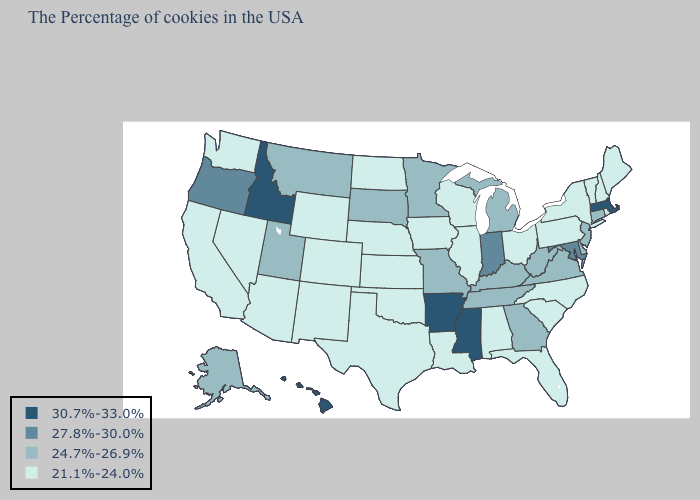Which states have the lowest value in the USA?
Keep it brief. Maine, Rhode Island, New Hampshire, Vermont, New York, Pennsylvania, North Carolina, South Carolina, Ohio, Florida, Alabama, Wisconsin, Illinois, Louisiana, Iowa, Kansas, Nebraska, Oklahoma, Texas, North Dakota, Wyoming, Colorado, New Mexico, Arizona, Nevada, California, Washington. Name the states that have a value in the range 21.1%-24.0%?
Give a very brief answer. Maine, Rhode Island, New Hampshire, Vermont, New York, Pennsylvania, North Carolina, South Carolina, Ohio, Florida, Alabama, Wisconsin, Illinois, Louisiana, Iowa, Kansas, Nebraska, Oklahoma, Texas, North Dakota, Wyoming, Colorado, New Mexico, Arizona, Nevada, California, Washington. What is the value of Rhode Island?
Answer briefly. 21.1%-24.0%. Does Wyoming have the highest value in the West?
Concise answer only. No. Among the states that border Tennessee , does Missouri have the highest value?
Concise answer only. No. What is the highest value in states that border Texas?
Write a very short answer. 30.7%-33.0%. Is the legend a continuous bar?
Concise answer only. No. What is the value of Alaska?
Write a very short answer. 24.7%-26.9%. Is the legend a continuous bar?
Write a very short answer. No. What is the value of Georgia?
Quick response, please. 24.7%-26.9%. Which states hav the highest value in the South?
Answer briefly. Mississippi, Arkansas. Which states have the highest value in the USA?
Concise answer only. Massachusetts, Mississippi, Arkansas, Idaho, Hawaii. Among the states that border Michigan , which have the lowest value?
Short answer required. Ohio, Wisconsin. What is the value of Wyoming?
Short answer required. 21.1%-24.0%. Among the states that border Montana , which have the highest value?
Short answer required. Idaho. 